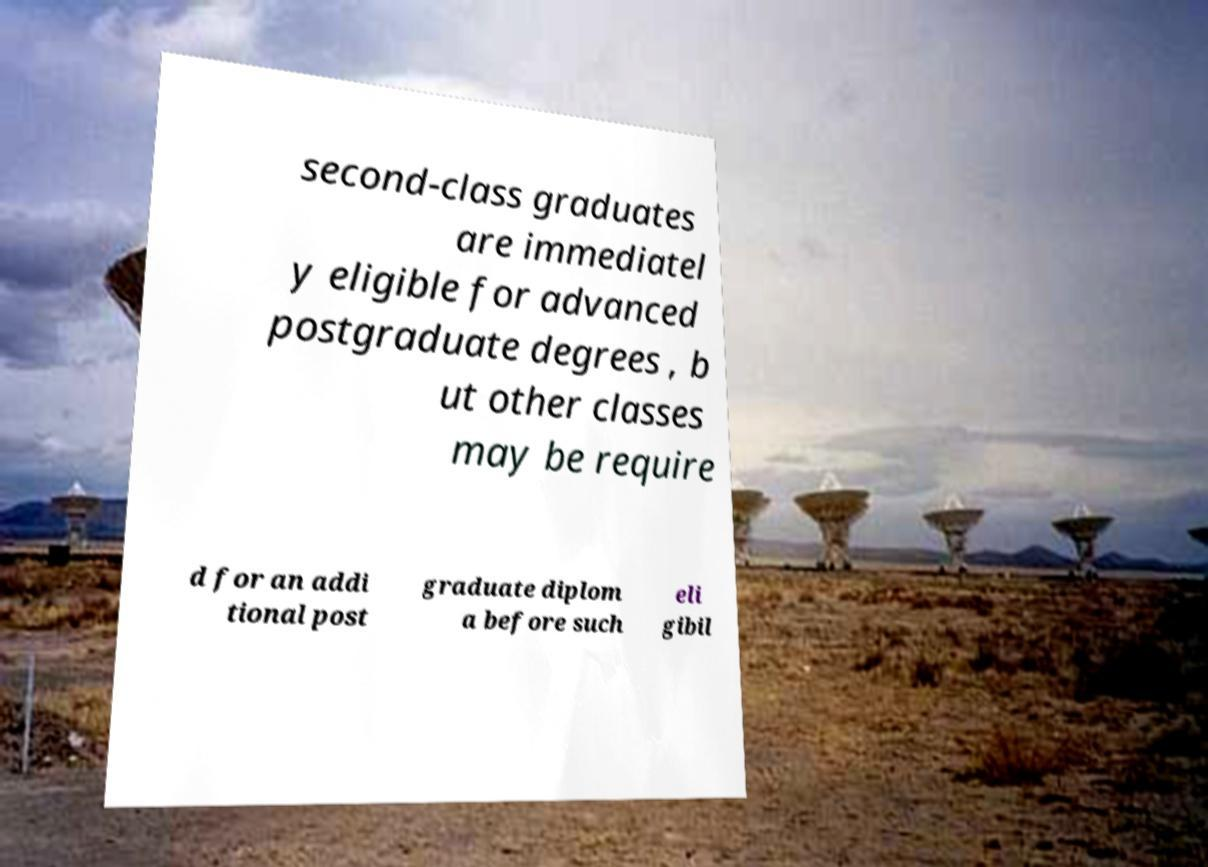Can you read and provide the text displayed in the image?This photo seems to have some interesting text. Can you extract and type it out for me? second-class graduates are immediatel y eligible for advanced postgraduate degrees , b ut other classes may be require d for an addi tional post graduate diplom a before such eli gibil 